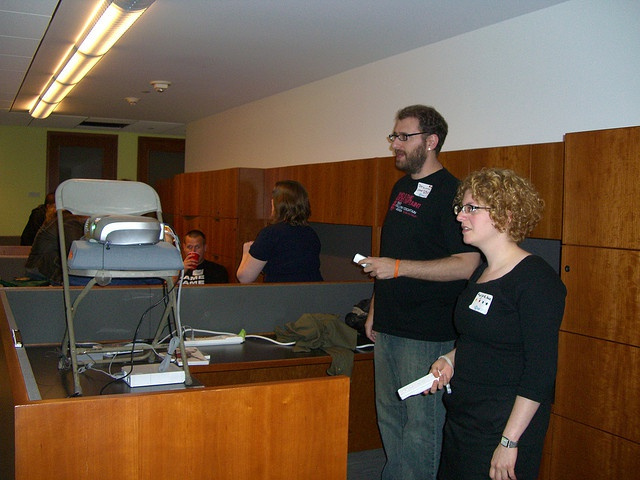Describe the objects in this image and their specific colors. I can see people in gray, black, and purple tones, people in gray, black, tan, and maroon tones, chair in gray, darkgray, and black tones, people in gray, black, and maroon tones, and people in gray, black, and maroon tones in this image. 